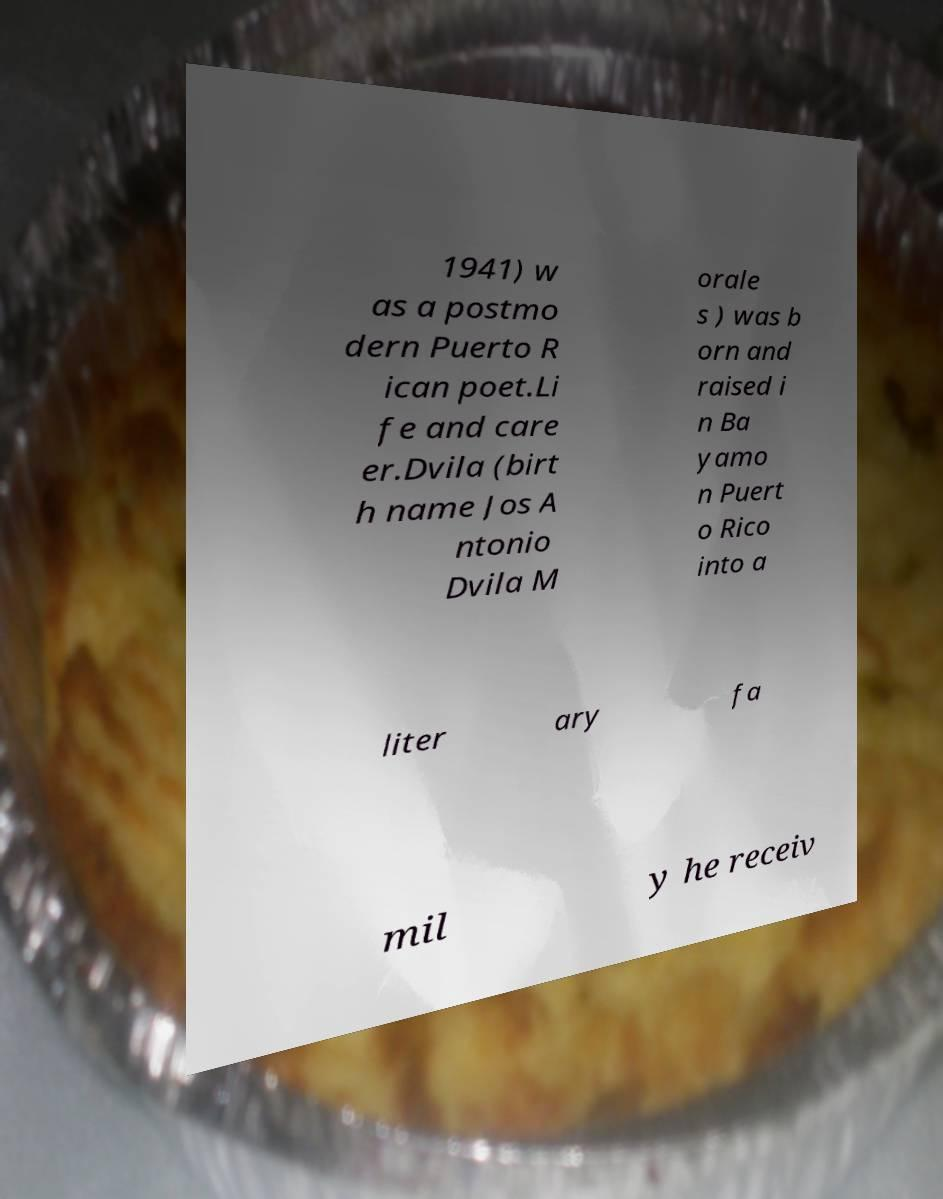Can you read and provide the text displayed in the image?This photo seems to have some interesting text. Can you extract and type it out for me? 1941) w as a postmo dern Puerto R ican poet.Li fe and care er.Dvila (birt h name Jos A ntonio Dvila M orale s ) was b orn and raised i n Ba yamo n Puert o Rico into a liter ary fa mil y he receiv 